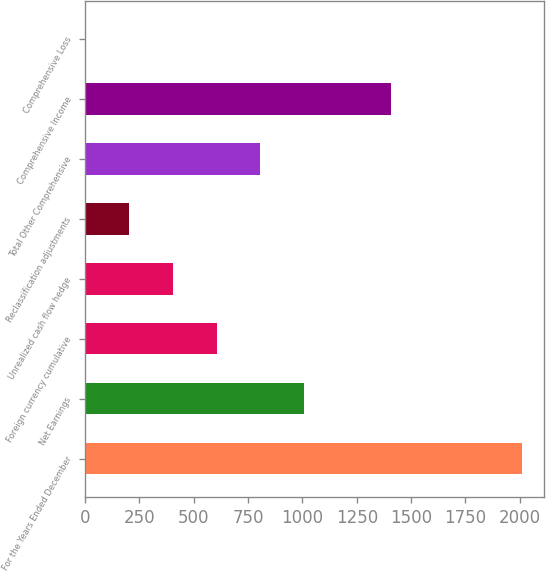<chart> <loc_0><loc_0><loc_500><loc_500><bar_chart><fcel>For the Years Ended December<fcel>Net Earnings<fcel>Foreign currency cumulative<fcel>Unrealized cash flow hedge<fcel>Reclassification adjustments<fcel>Total Other Comprehensive<fcel>Comprehensive Income<fcel>Comprehensive Loss<nl><fcel>2012<fcel>1007.1<fcel>605.14<fcel>404.16<fcel>203.18<fcel>806.12<fcel>1409.06<fcel>2.2<nl></chart> 